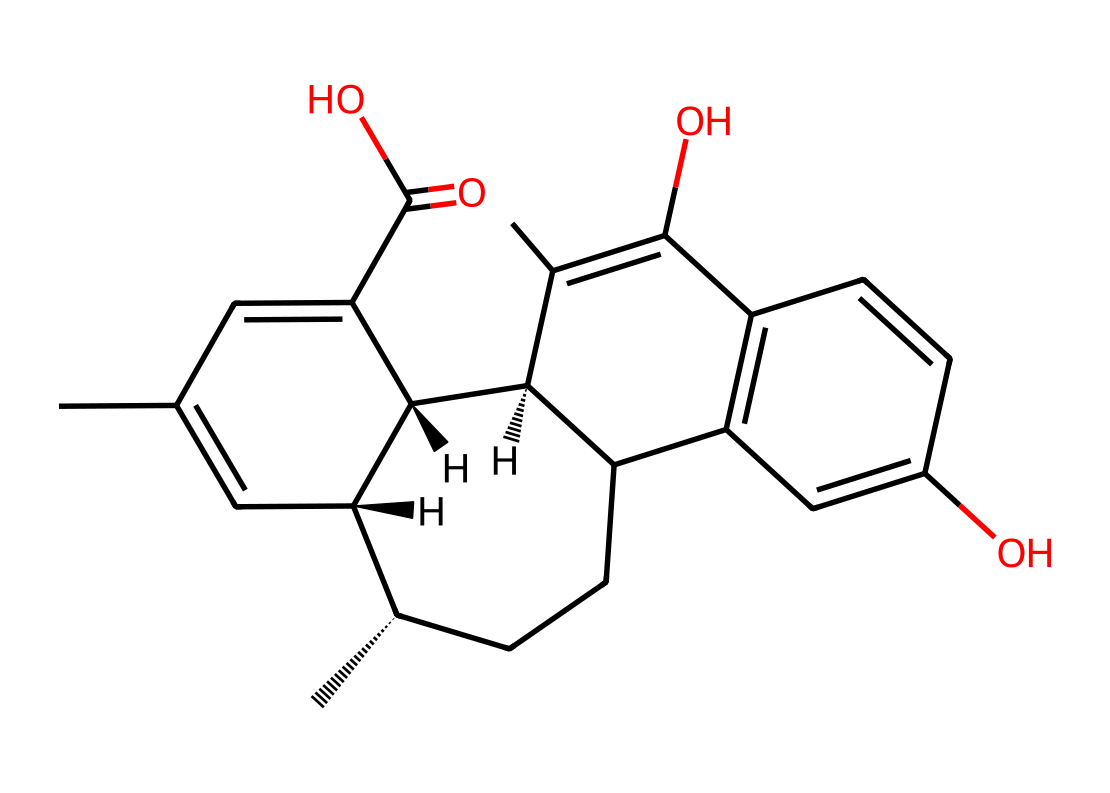What is the name of this chemical compound? The SMILES notation corresponds to cannabidiol, commonly known as CBD, which is derived from the cannabis plant.
Answer: cannabidiol How many carbon atoms are present in this structure? By counting the 'C' in the SMILES representation and accounting for the connections, this structure has 21 carbon atoms.
Answer: 21 What type of bonding is primarily present in this chemical structure? The structure is largely composed of single and double bonds; however, the presence of double bonds is significant, indicating it contains unsaturation.
Answer: double bonds What functional groups are found in this molecule? Upon examining the structure, we identify a carboxylic acid (C(=O)O) and hydroxyl groups (–OH) which are characteristic functional groups in this compound.
Answer: carboxylic acid and hydroxyl groups How many rings are present in the structure of CBD? There are a total of 2 rings in the structure, which are indicated by the cyclic parts of the SMILES notation where the numbers denote the start and end of the ring connections.
Answer: 2 Which part of the structure is likely responsible for its potential therapeutic effects? The presence of hydroxyl groups and the overall cyclic structure allow for interaction with biological targets, contributing to its therapeutic properties, enhancing creativity and reducing anxiety in users.
Answer: hydroxyl groups 